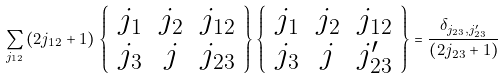Convert formula to latex. <formula><loc_0><loc_0><loc_500><loc_500>\sum _ { j _ { 1 2 } } \left ( 2 j _ { 1 2 } + 1 \right ) \, \left \{ \begin{array} { c c c } j _ { 1 } & j _ { 2 } & j _ { 1 2 } \\ j _ { 3 } & j & j _ { 2 3 } \end{array} \right \} \left \{ \begin{array} { c c c } j _ { 1 } & j _ { 2 } & j _ { 1 2 } \\ j _ { 3 } & j & j _ { 2 3 } ^ { \prime } \end{array} \right \} = \frac { \delta _ { j _ { 2 3 } , j _ { 2 3 } ^ { \prime } } } { \left ( 2 j _ { 2 3 } + 1 \right ) }</formula> 